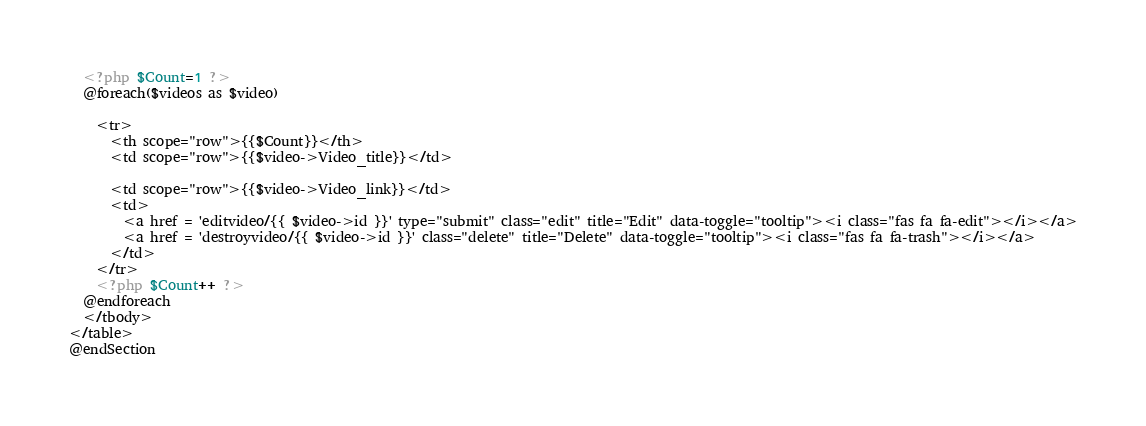Convert code to text. <code><loc_0><loc_0><loc_500><loc_500><_PHP_>  <?php $Count=1 ?>
  @foreach($videos as $video)
  
    <tr>
      <th scope="row">{{$Count}}</th>
      <td scope="row">{{$video->Video_title}}</td>
 
      <td scope="row">{{$video->Video_link}}</td>
      <td>
        <a href = 'editvideo/{{ $video->id }}' type="submit" class="edit" title="Edit" data-toggle="tooltip"><i class="fas fa fa-edit"></i></a>
        <a href = 'destroyvideo/{{ $video->id }}' class="delete" title="Delete" data-toggle="tooltip"><i class="fas fa fa-trash"></i></a>
      </td>
    </tr>
    <?php $Count++ ?>
  @endforeach   
  </tbody>
</table>
@endSection</code> 